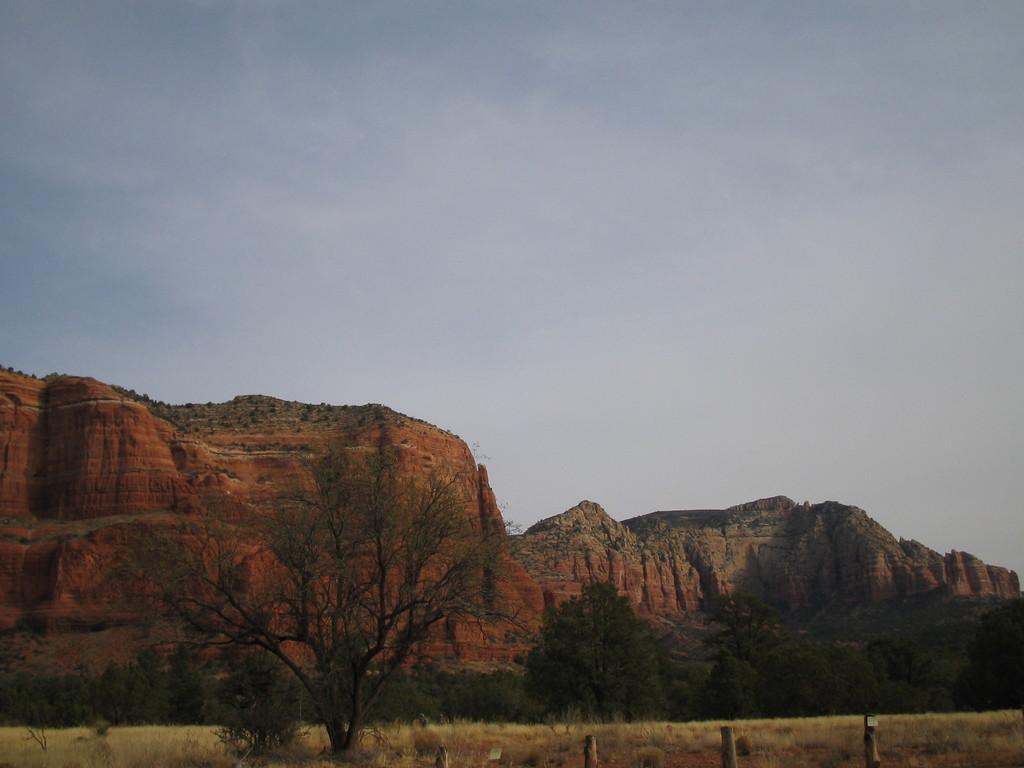How would you summarize this image in a sentence or two? This is an outside view. At the bottom of the image I can see the trees and hills. At the top, I can see the sky. 